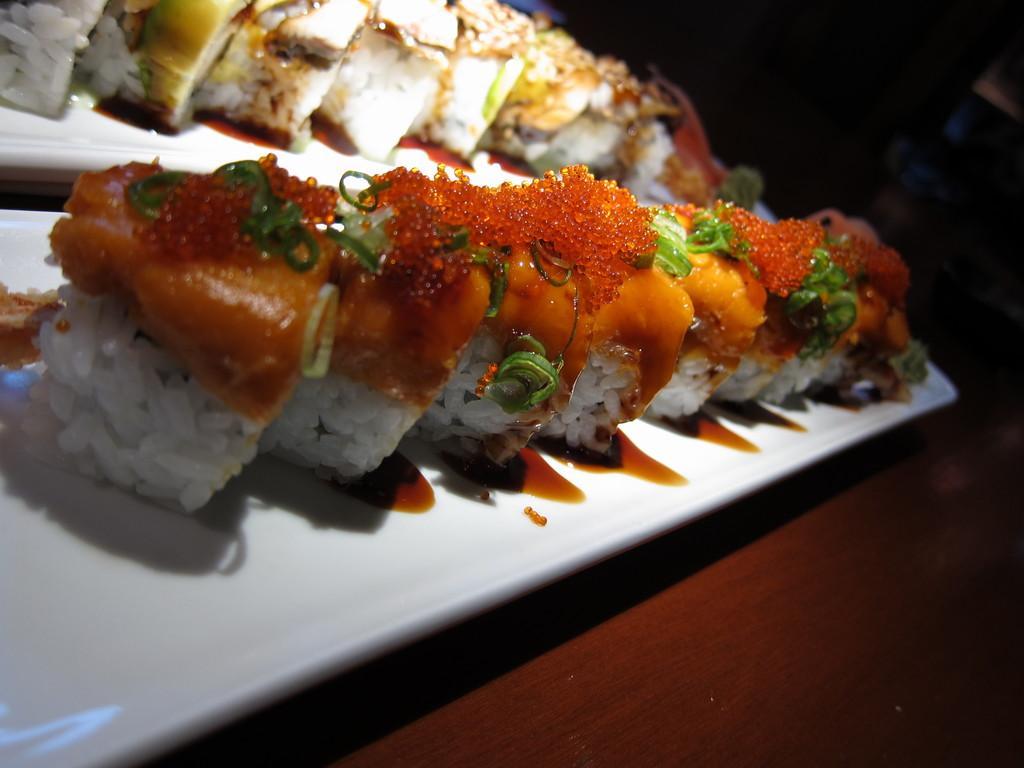Please provide a concise description of this image. In this image we can see food items in the plates on a platform. In the background the image is dark. 